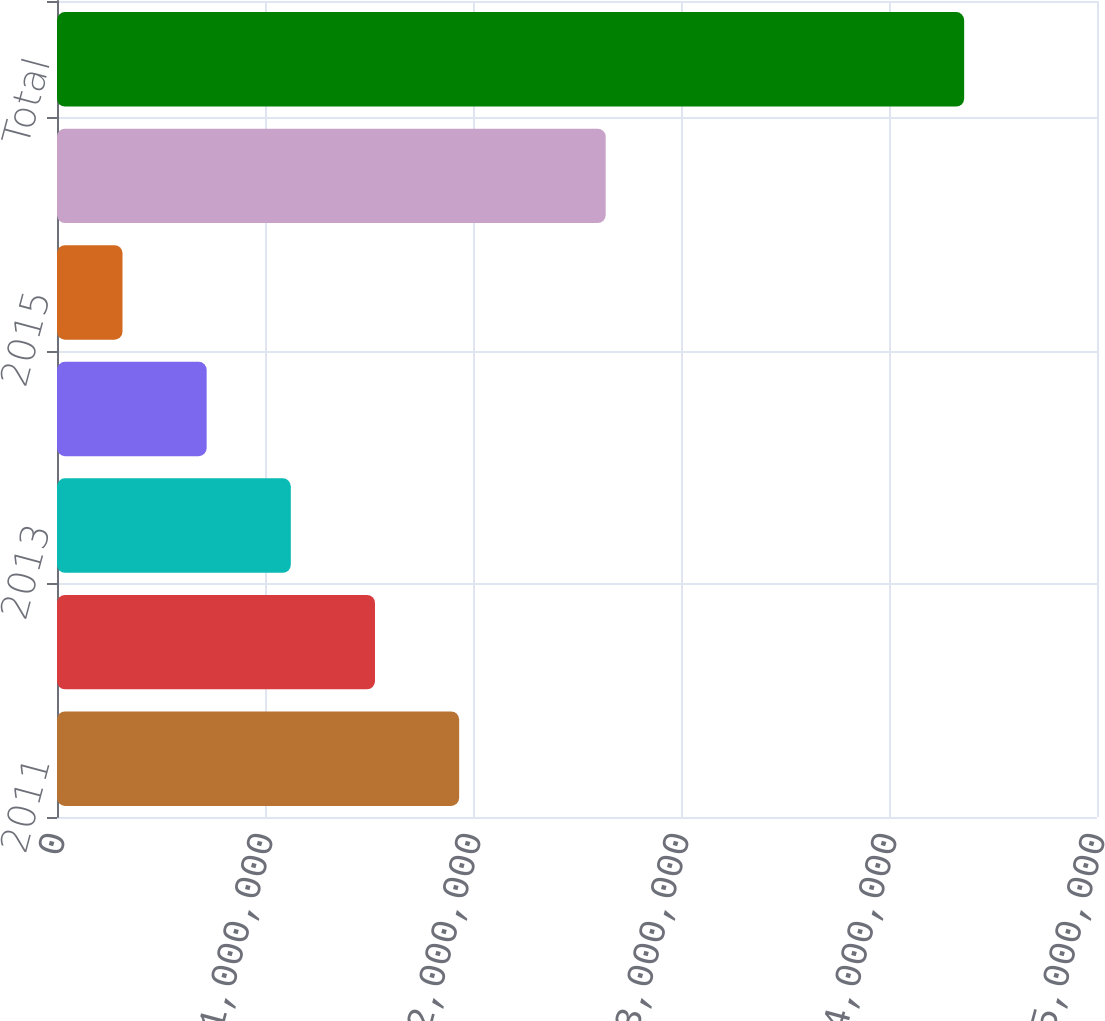<chart> <loc_0><loc_0><loc_500><loc_500><bar_chart><fcel>2011<fcel>2012<fcel>2013<fcel>2014<fcel>2015<fcel>Thereafter<fcel>Total<nl><fcel>1.93344e+06<fcel>1.52879e+06<fcel>1.12415e+06<fcel>719501<fcel>314855<fcel>2.63794e+06<fcel>4.36132e+06<nl></chart> 